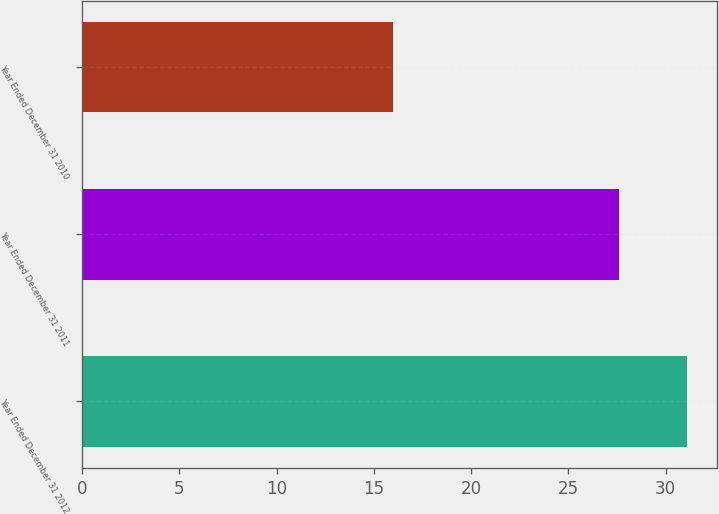<chart> <loc_0><loc_0><loc_500><loc_500><bar_chart><fcel>Year Ended December 31 2012<fcel>Year Ended December 31 2011<fcel>Year Ended December 31 2010<nl><fcel>31.1<fcel>27.6<fcel>16<nl></chart> 